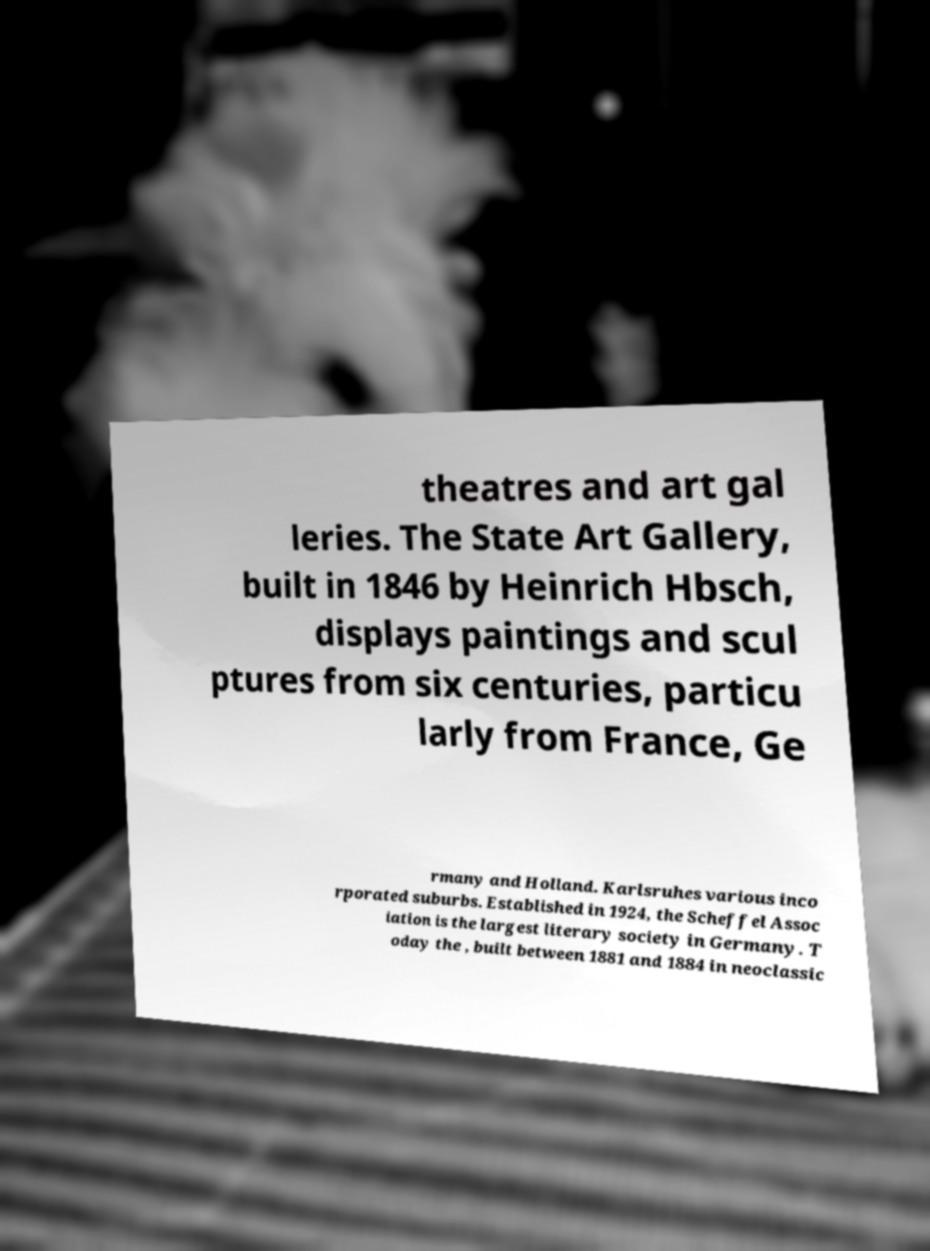For documentation purposes, I need the text within this image transcribed. Could you provide that? theatres and art gal leries. The State Art Gallery, built in 1846 by Heinrich Hbsch, displays paintings and scul ptures from six centuries, particu larly from France, Ge rmany and Holland. Karlsruhes various inco rporated suburbs. Established in 1924, the Scheffel Assoc iation is the largest literary society in Germany. T oday the , built between 1881 and 1884 in neoclassic 